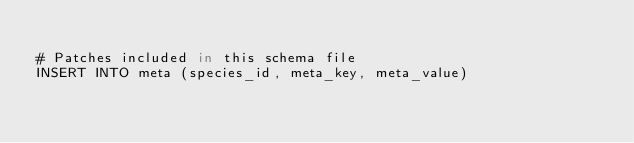<code> <loc_0><loc_0><loc_500><loc_500><_SQL_>
# Patches included in this schema file
INSERT INTO meta (species_id, meta_key, meta_value)</code> 